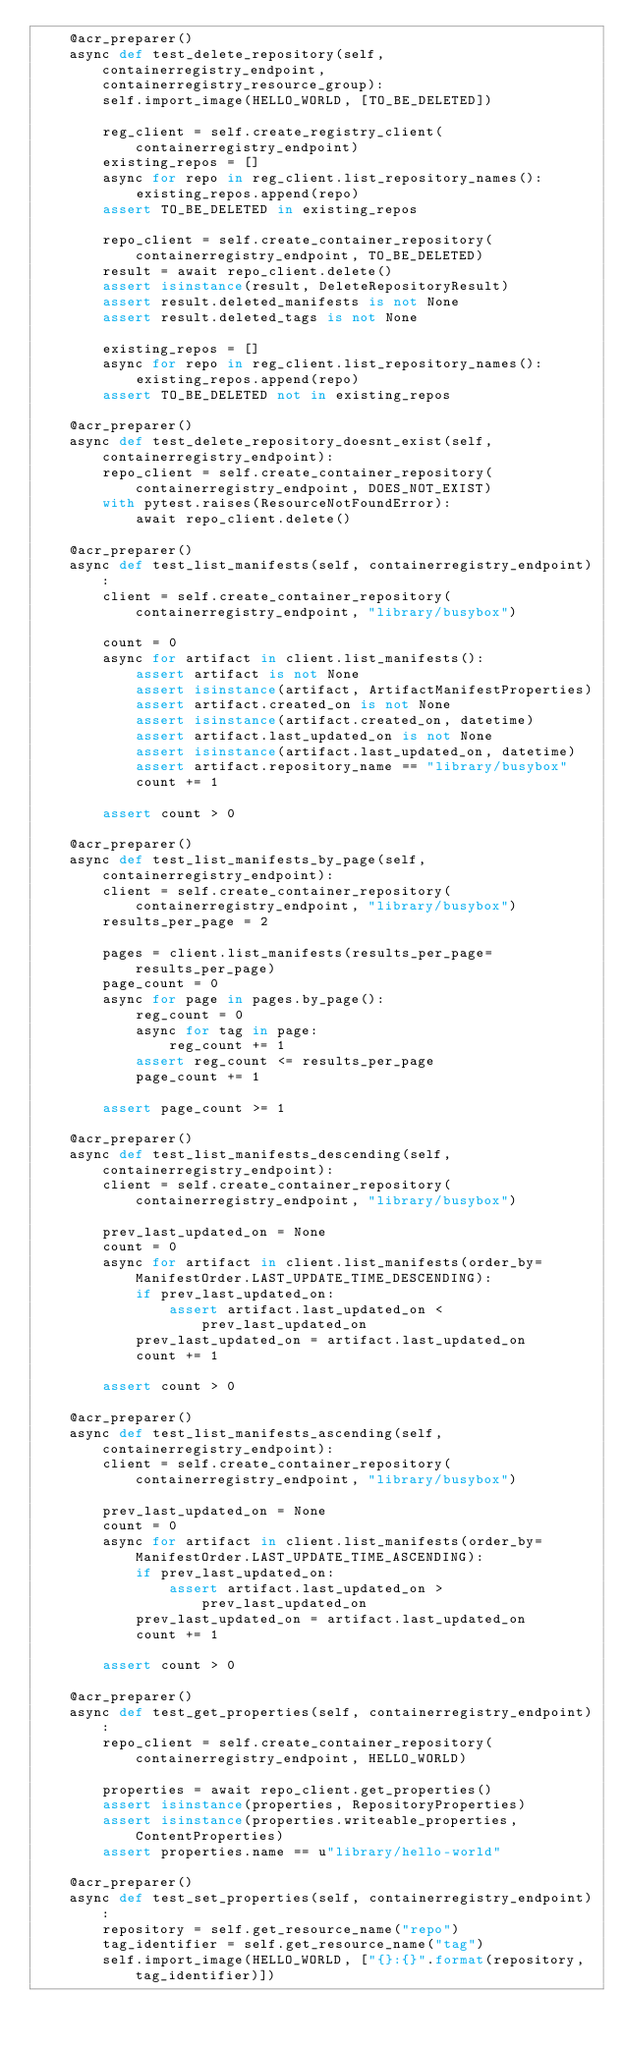<code> <loc_0><loc_0><loc_500><loc_500><_Python_>    @acr_preparer()
    async def test_delete_repository(self, containerregistry_endpoint, containerregistry_resource_group):
        self.import_image(HELLO_WORLD, [TO_BE_DELETED])

        reg_client = self.create_registry_client(containerregistry_endpoint)
        existing_repos = []
        async for repo in reg_client.list_repository_names():
            existing_repos.append(repo)
        assert TO_BE_DELETED in existing_repos

        repo_client = self.create_container_repository(containerregistry_endpoint, TO_BE_DELETED)
        result = await repo_client.delete()
        assert isinstance(result, DeleteRepositoryResult)
        assert result.deleted_manifests is not None
        assert result.deleted_tags is not None

        existing_repos = []
        async for repo in reg_client.list_repository_names():
            existing_repos.append(repo)
        assert TO_BE_DELETED not in existing_repos

    @acr_preparer()
    async def test_delete_repository_doesnt_exist(self, containerregistry_endpoint):
        repo_client = self.create_container_repository(containerregistry_endpoint, DOES_NOT_EXIST)
        with pytest.raises(ResourceNotFoundError):
            await repo_client.delete()

    @acr_preparer()
    async def test_list_manifests(self, containerregistry_endpoint):
        client = self.create_container_repository(containerregistry_endpoint, "library/busybox")

        count = 0
        async for artifact in client.list_manifests():
            assert artifact is not None
            assert isinstance(artifact, ArtifactManifestProperties)
            assert artifact.created_on is not None
            assert isinstance(artifact.created_on, datetime)
            assert artifact.last_updated_on is not None
            assert isinstance(artifact.last_updated_on, datetime)
            assert artifact.repository_name == "library/busybox"
            count += 1

        assert count > 0

    @acr_preparer()
    async def test_list_manifests_by_page(self, containerregistry_endpoint):
        client = self.create_container_repository(containerregistry_endpoint, "library/busybox")
        results_per_page = 2

        pages = client.list_manifests(results_per_page=results_per_page)
        page_count = 0
        async for page in pages.by_page():
            reg_count = 0
            async for tag in page:
                reg_count += 1
            assert reg_count <= results_per_page
            page_count += 1

        assert page_count >= 1

    @acr_preparer()
    async def test_list_manifests_descending(self, containerregistry_endpoint):
        client = self.create_container_repository(containerregistry_endpoint, "library/busybox")

        prev_last_updated_on = None
        count = 0
        async for artifact in client.list_manifests(order_by=ManifestOrder.LAST_UPDATE_TIME_DESCENDING):
            if prev_last_updated_on:
                assert artifact.last_updated_on < prev_last_updated_on
            prev_last_updated_on = artifact.last_updated_on
            count += 1

        assert count > 0

    @acr_preparer()
    async def test_list_manifests_ascending(self, containerregistry_endpoint):
        client = self.create_container_repository(containerregistry_endpoint, "library/busybox")

        prev_last_updated_on = None
        count = 0
        async for artifact in client.list_manifests(order_by=ManifestOrder.LAST_UPDATE_TIME_ASCENDING):
            if prev_last_updated_on:
                assert artifact.last_updated_on > prev_last_updated_on
            prev_last_updated_on = artifact.last_updated_on
            count += 1

        assert count > 0

    @acr_preparer()
    async def test_get_properties(self, containerregistry_endpoint):
        repo_client = self.create_container_repository(containerregistry_endpoint, HELLO_WORLD)

        properties = await repo_client.get_properties()
        assert isinstance(properties, RepositoryProperties)
        assert isinstance(properties.writeable_properties, ContentProperties)
        assert properties.name == u"library/hello-world"

    @acr_preparer()
    async def test_set_properties(self, containerregistry_endpoint):
        repository = self.get_resource_name("repo")
        tag_identifier = self.get_resource_name("tag")
        self.import_image(HELLO_WORLD, ["{}:{}".format(repository, tag_identifier)])</code> 